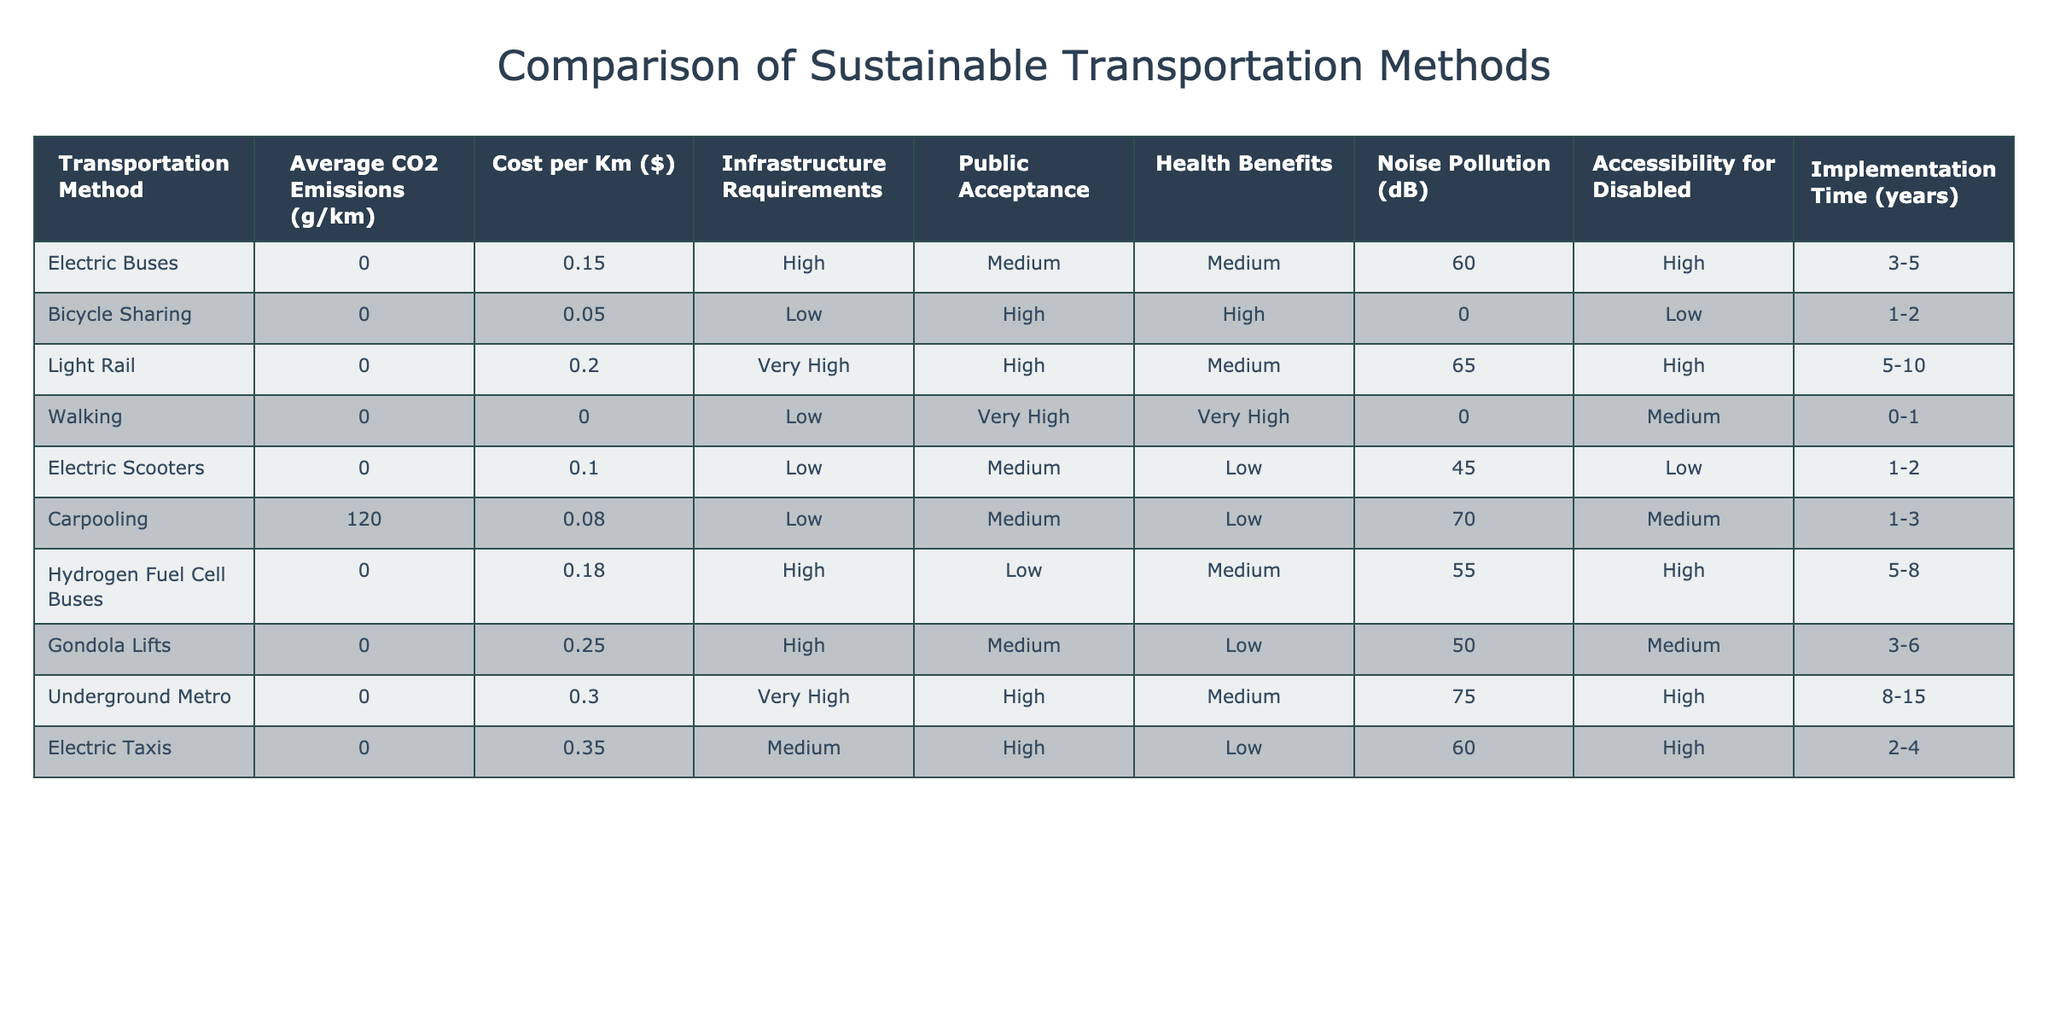What is the average cost per kilometer for bicycle sharing? The cost per kilometer for bicycle sharing is listed in the table as $0.05. This is directly retrieved from the corresponding column in the table.
Answer: $0.05 What is the implementation time for electric taxis? The implementation time for electric taxis is provided in the table as 2-4 years, which is taken directly from the relevant row in the table.
Answer: 2-4 years Is walking associated with any noise pollution? According to the table, the noise pollution for walking is listed as 0 dB, indicating that it does not contribute to noise. Thus, the answer to whether there is noise pollution is no.
Answer: No Which transportation method has the highest average CO2 emissions, and what is that value? The transportation method with the highest average CO2 emissions is carpooling, which has an average of 120 g/km. This information is found by comparing the values in the CO2 emissions column for all methods.
Answer: Carpooling, 120 g/km What is the difference in cost per kilometer between electric taxis and electric buses? The cost per kilometer for electric taxis is $0.35, and for electric buses, it is $0.15. By subtracting the cost of electric buses from that of electric taxis: $0.35 - $0.15 = $0.20, we find the difference.
Answer: $0.20 Which transportation methods have high public acceptance and low infrastructure requirements? By analyzing the table, bicycle sharing and carpooling are both listed as having high public acceptance and low infrastructure requirements. This is determined by checking both categories in the respective rows.
Answer: Bicycle sharing, Carpooling If we summarize the health benefits, which method shows the most significant health benefits return relative to its cost? Health benefits are high for bicycle sharing, but its cost ($0.05) is much lower than the cost of electric taxis which have low health benefits. Hence, bicycle sharing offers the best health benefits return relative to cost.
Answer: Bicycle Sharing What is the average noise pollution level of light rail and underground metro combined? The noise pollution level for light rail is 65 dB and for underground metro is 75 dB. To find the average, we add these values together (65 + 75 = 140) and then divide by the number of methods (2). Thus, the average is 140 / 2 = 70 dB.
Answer: 70 dB 